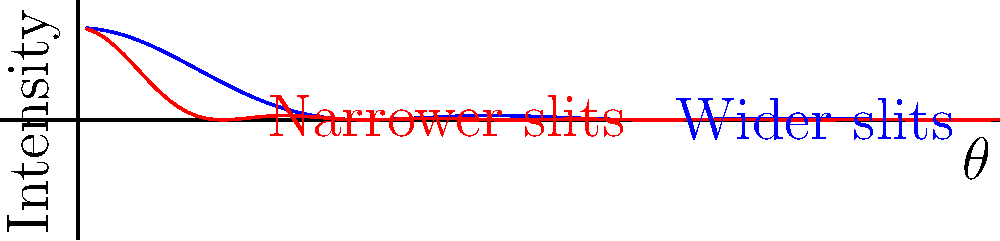The diagram shows the interference patterns for a double-slit experiment with two different slit widths. How does reducing the slit width affect the central maximum and the spacing between interference fringes? Explain the underlying physics principle. To understand the effect of slit width on the interference pattern, we need to consider the following steps:

1. The width of the central maximum:
   - The width of the central maximum is inversely proportional to the slit width.
   - This is described by the equation: $\Delta \theta \approx \frac{\lambda}{a}$, where $\Delta \theta$ is the angular width of the central maximum, $\lambda$ is the wavelength, and $a$ is the slit width.

2. Spacing between interference fringes:
   - The spacing between fringes is determined by the distance between the slits, not the slit width.
   - It is given by the equation: $\Delta y = \frac{\lambda L}{d}$, where $\Delta y$ is the fringe spacing, $L$ is the distance to the screen, and $d$ is the distance between slits.

3. Effect of reducing slit width:
   - When the slit width is reduced, the central maximum becomes wider.
   - This is because narrower slits allow for greater diffraction, spreading out the light more.

4. Underlying physics principle:
   - This behavior is explained by the Fraunhofer diffraction pattern of a single slit combined with the interference pattern of two slits.
   - The envelope of the interference pattern is modulated by the single-slit diffraction pattern.

5. Intensity distribution:
   - The intensity distribution is given by: $I = I_0 (\frac{\sin \beta}{\beta})^2 \cos^2 \alpha$
   - Where $\beta = \frac{\pi a \sin \theta}{\lambda}$ and $\alpha = \frac{\pi d \sin \theta}{\lambda}$
   - $a$ is the slit width, $d$ is the slit separation, and $\theta$ is the angle from the central maximum.

In the diagram, the blue curve represents wider slits, showing a narrower central maximum and more visible higher-order maxima. The red curve represents narrower slits, showing a wider central maximum with fewer visible higher-order maxima.
Answer: Reducing slit width widens the central maximum but doesn't affect fringe spacing. 